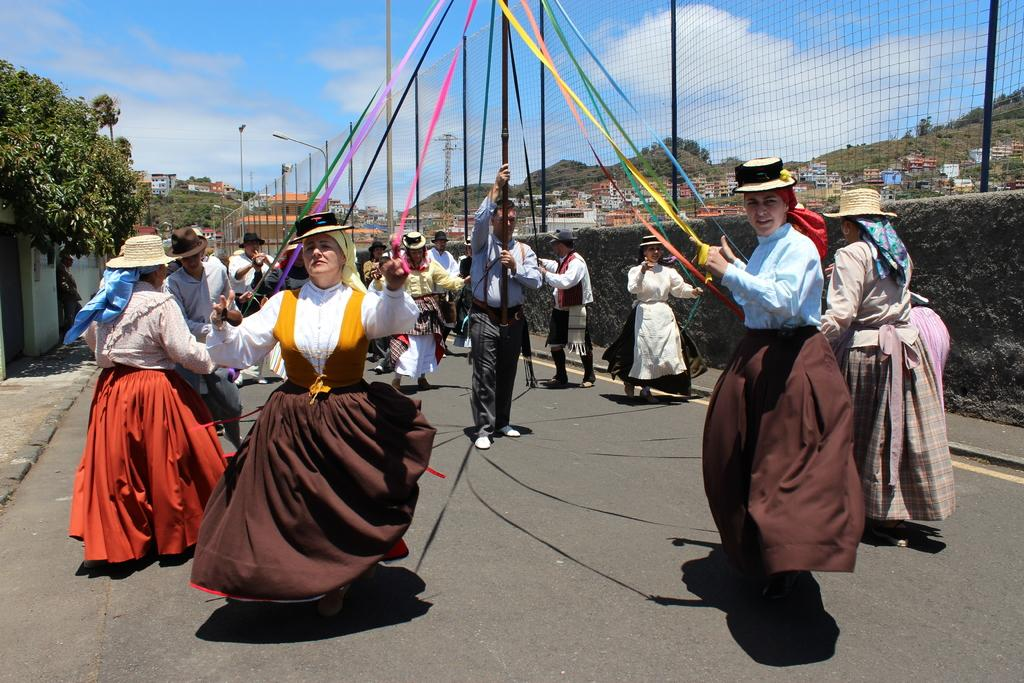How many people are in the image? There are people in the image, but the exact number is not specified. What are some people holding in the image? Some people are holding objects in the image, but the specific objects are not mentioned. What type of ground surface can be seen in the image? There is a road in the image, which suggests a ground surface for vehicles. What type of structures can be seen in the image? There are walls, buildings, and poles in the image, indicating various types of structures. What type of natural elements can be seen in the image? There are trees and mountains in the image, showcasing natural elements. What is present in the image for sports or recreational activities? There is a net in the image, which could be used for sports or recreational activities. What type of artificial light sources are visible in the image? There are lights in the image, which suggests artificial light sources. What is visible in the sky in the image? The sky is visible in the image, and clouds are present. What type of soup is being served in the image? There is no soup present in the image. What type of pet can be seen in the image? There is no pet present in the image. 